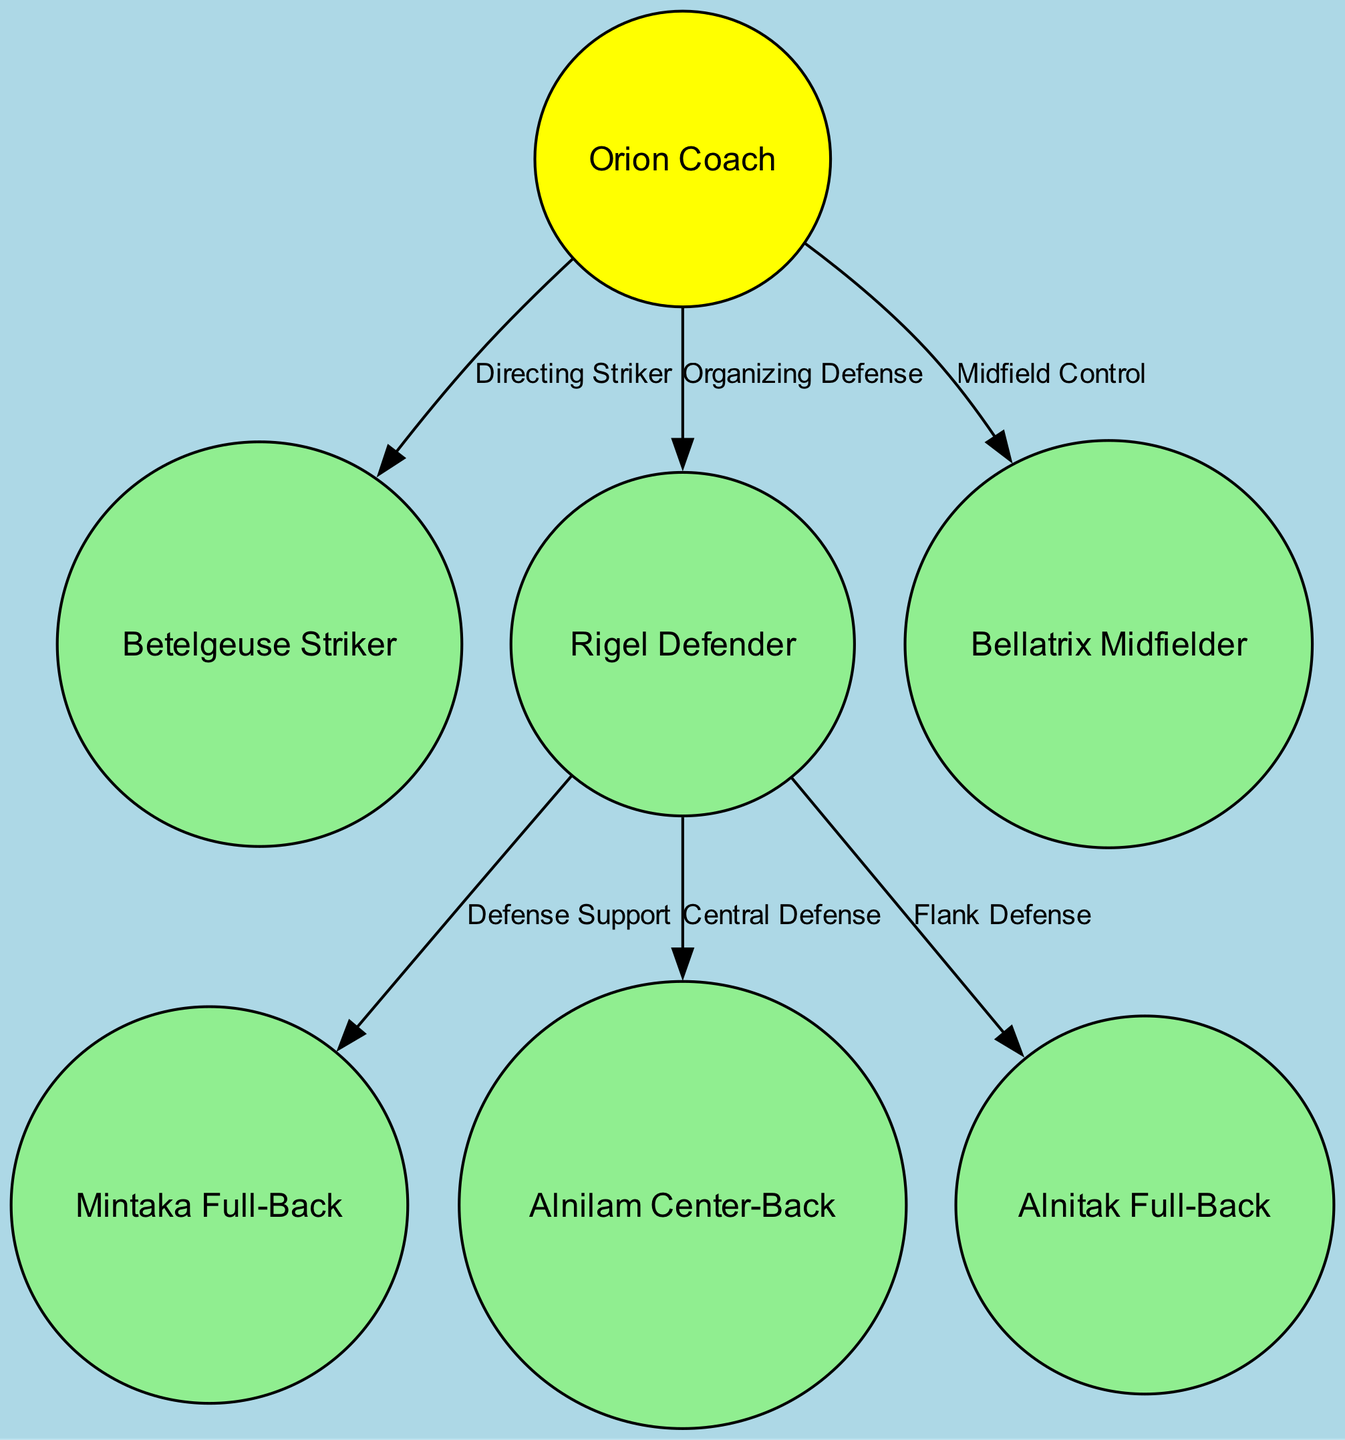What's the total number of nodes in the diagram? The diagram includes seven nodes: Orion Coach, Betelgeuse Striker, Rigel Defender, Bellatrix Midfielder, Mintaka Full-Back, Alnilam Center-Back, and Alnitak Full-Back. Counting these gives a total of seven.
Answer: 7 Who is responsible for midfield control? The diagram indicates that the Bellatrix Midfielder is responsible for midfield control, as indicated by the link and description associated with that node.
Answer: Bellatrix Midfielder What is the primary role of the Betelgeuse Striker? The Betelgeuse Striker's role is clearly defined in the diagram as the primary goal scorer, represented by its description and position in the structure.
Answer: Primary goal scorer Which node has a connection to both the Mintaka Full-Back and Alnitak Full-Back? The Rigel Defender node has connections to both the Mintaka Full-Back and Alnitak Full-Back, as shown by the edges leading from Rigel Defender to these two full-backs.
Answer: Rigel Defender What does the edge labeled "Organizing Defense" signify? The edge labeled "Organizing Defense" signifies that the Orion Coach is coordinating defensive strategies involving the Rigel Defender, indicated by the descriptive label on the edge.
Answer: Coach coordinates defensive strategies What star does the Rigel Defender represent? The Rigel Defender represents the bright blue supergiant star in the Orion constellation, as described in the node's details.
Answer: Bright blue supergiant star How many edges are present in the diagram? The diagram shows a total of six edges connecting the nodes, which can be counted based on the connections indicated between different roles.
Answer: 6 Which node supports the Mintaka Full-Back? The Rigel Defender supports the Mintaka Full-Back, as indicated by the edge labeled "Defense Support" that connects Rigel Defender to Mintaka Full-Back.
Answer: Rigel Defender What role does the Alnilam Center-Back serve? The Alnilam Center-Back serves as the central defense, which is specified in both the node's label and its description in the diagram.
Answer: Central defense 